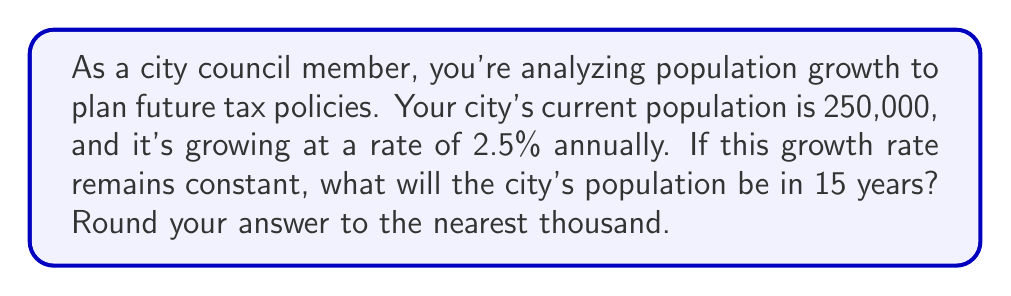Can you solve this math problem? Let's approach this step-by-step using an exponential growth model:

1) The exponential growth formula is:
   $A = P(1 + r)^t$
   Where:
   $A$ = Final amount
   $P$ = Initial amount (population)
   $r$ = Growth rate (as a decimal)
   $t$ = Time (in years)

2) We know:
   $P = 250,000$
   $r = 2.5\% = 0.025$
   $t = 15$ years

3) Let's plug these values into our formula:
   $A = 250,000(1 + 0.025)^{15}$

4) Simplify inside the parentheses:
   $A = 250,000(1.025)^{15}$

5) Now, let's calculate $(1.025)^{15}$:
   $(1.025)^{15} \approx 1.4463$ (rounded to 4 decimal places)

6) Multiply:
   $A = 250,000 \times 1.4463 = 361,575$

7) Rounding to the nearest thousand:
   $A \approx 362,000$
Answer: 362,000 